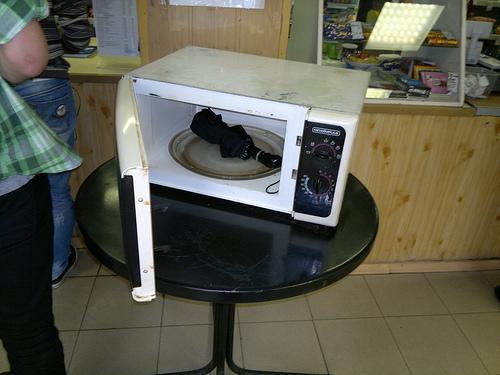How many microwaves are there?
Give a very brief answer. 1. 